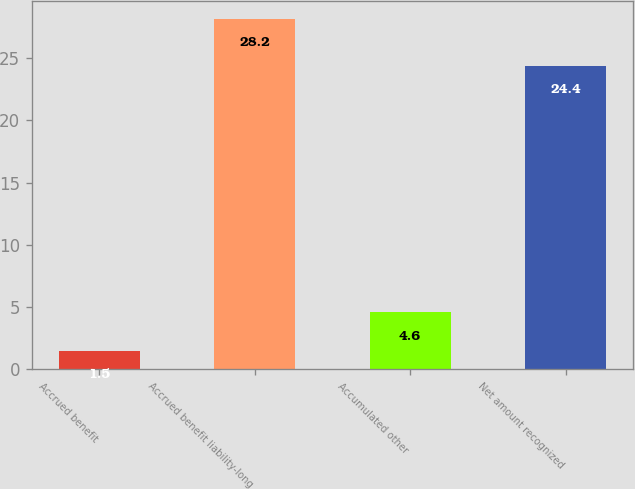Convert chart to OTSL. <chart><loc_0><loc_0><loc_500><loc_500><bar_chart><fcel>Accrued benefit<fcel>Accrued benefit liability-long<fcel>Accumulated other<fcel>Net amount recognized<nl><fcel>1.5<fcel>28.2<fcel>4.6<fcel>24.4<nl></chart> 